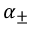Convert formula to latex. <formula><loc_0><loc_0><loc_500><loc_500>\alpha _ { \pm }</formula> 